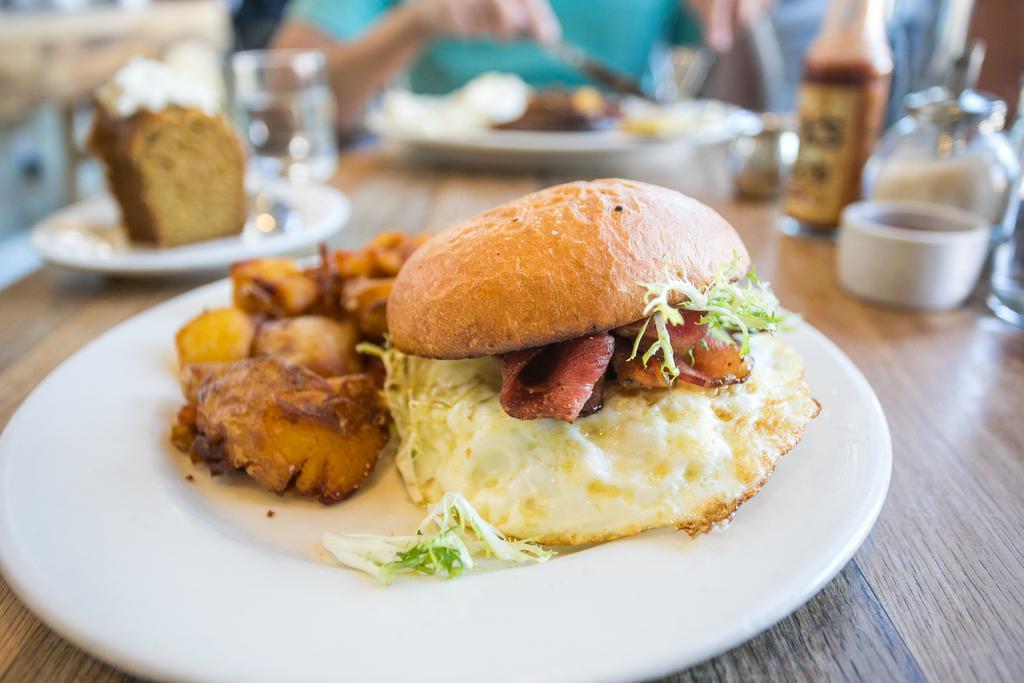Could you give a brief overview of what you see in this image? There are some eatables on the table. 